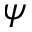Convert formula to latex. <formula><loc_0><loc_0><loc_500><loc_500>\psi</formula> 